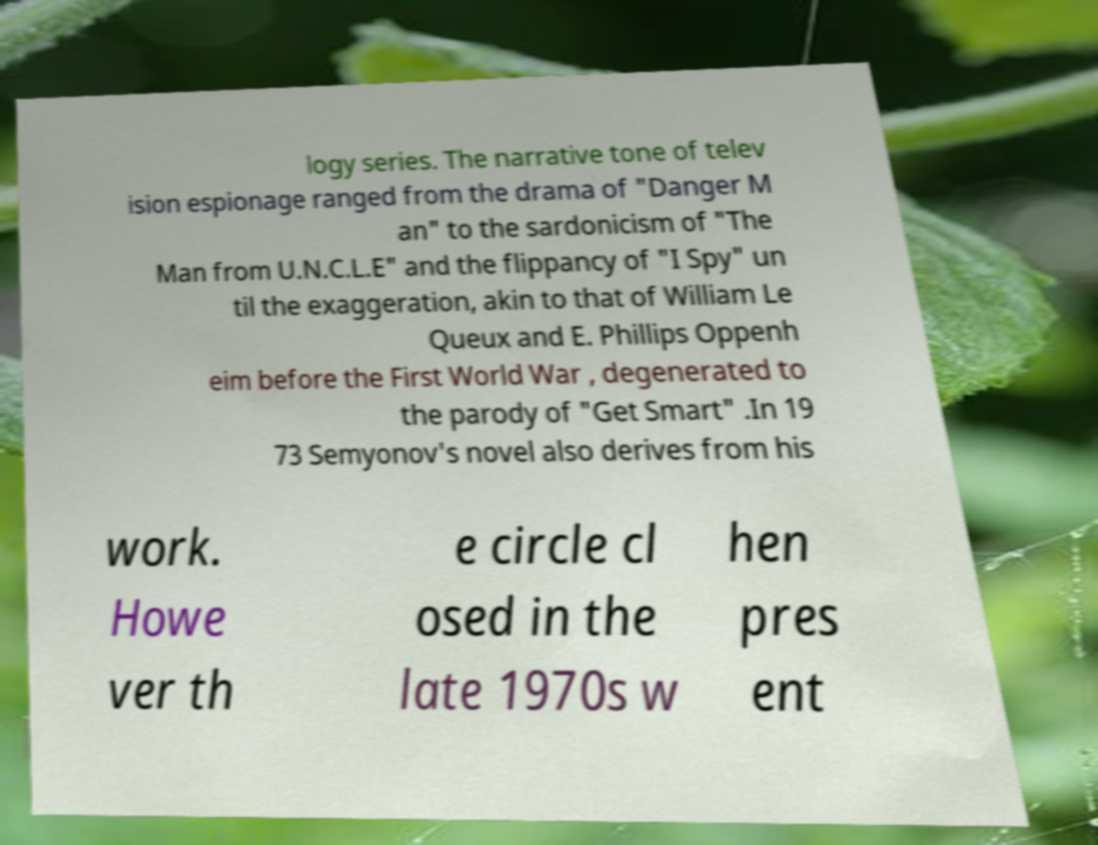Please identify and transcribe the text found in this image. logy series. The narrative tone of telev ision espionage ranged from the drama of "Danger M an" to the sardonicism of "The Man from U.N.C.L.E" and the flippancy of "I Spy" un til the exaggeration, akin to that of William Le Queux and E. Phillips Oppenh eim before the First World War , degenerated to the parody of "Get Smart" .In 19 73 Semyonov's novel also derives from his work. Howe ver th e circle cl osed in the late 1970s w hen pres ent 